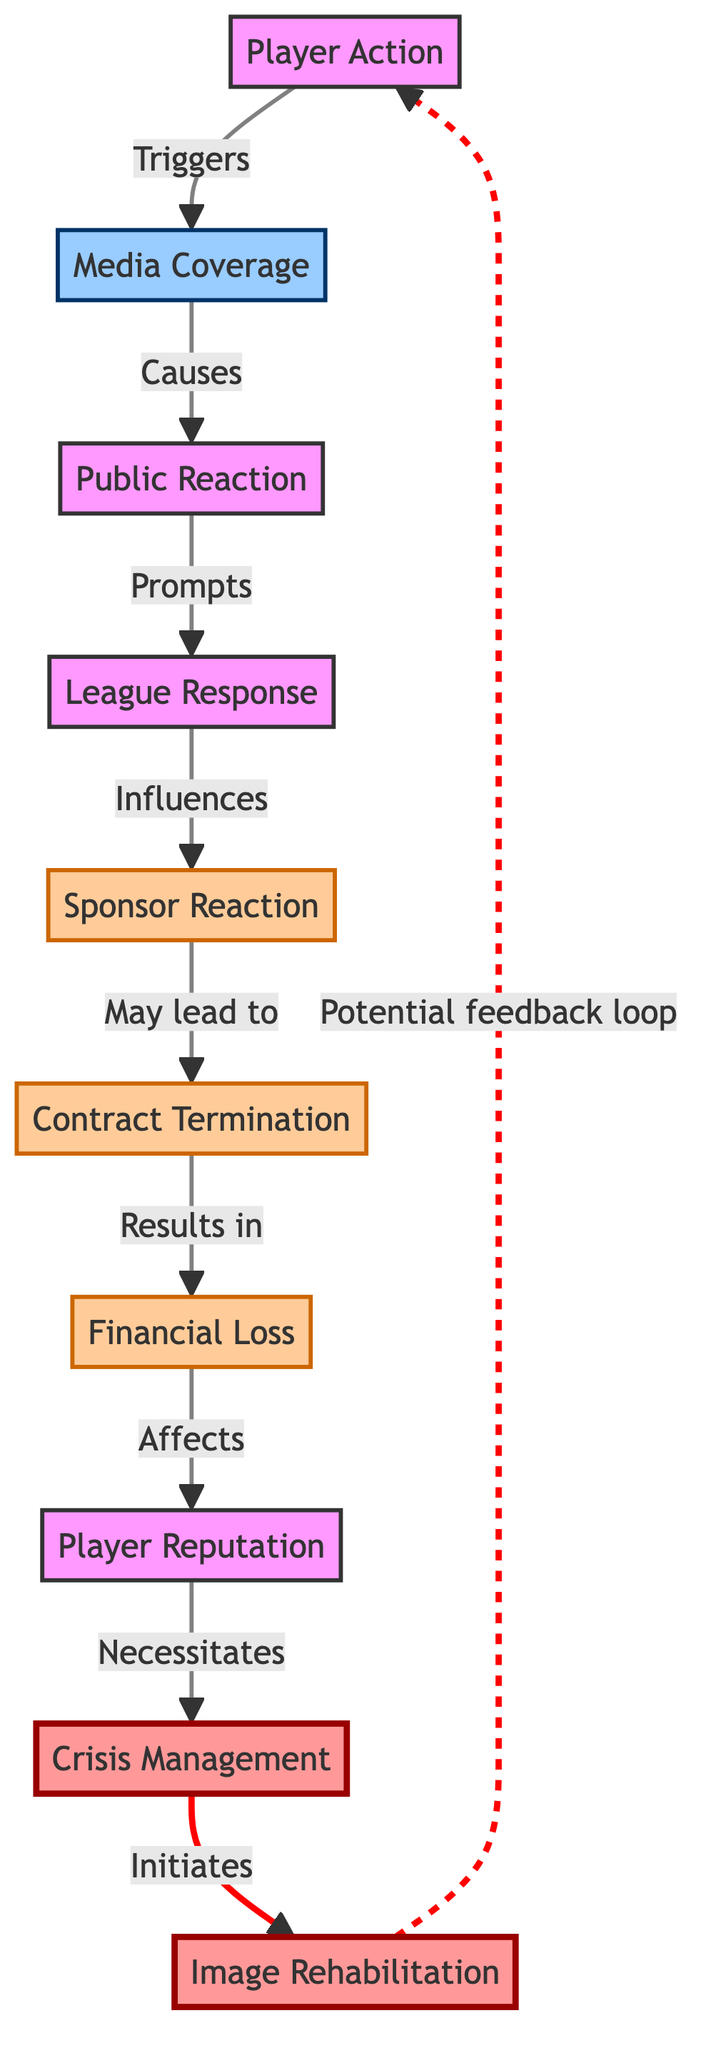What triggers media coverage? The diagram indicates that Player Action triggers Media Coverage. Player actions, such as issues on or off the field, can attract the attention of the media.
Answer: Player Action What leads to financial loss? The diagram shows that Contract Termination may lead to Financial Loss. When sponsorship contracts are terminated, this directly results in a loss of income for the player.
Answer: Contract Termination How does public reaction influence sponsor reaction? From the diagram, Public Reaction prompts League Response, which in turn influences Sponsor Reaction. This indicates a chain where the public's sentiment can affect how sponsors react to a situation.
Answer: Influences What follows after crisis management? According to the diagram, after Crisis Management, Image Rehabilitation is initiated. This indicates the process of restoring a player's public image following a negative event.
Answer: Image Rehabilitation How many nodes are in the diagram? The diagram consists of a total of 10 nodes, including Player Action, Media Coverage, Public Reaction, League Response, Sponsor Reaction, Contract Termination, Financial Loss, Player Reputation, Crisis Management, and Image Rehabilitation.
Answer: 10 Which node is affected by financial loss? Financial Loss affects Player Reputation according to the diagram. This suggests that losing financial support can lead to a negative perception of the player by fans and sponsors.
Answer: Player Reputation What is the response from the league after public reaction? The League Response follows Public Reaction as indicated in the diagram. This shows that the league takes action based on how the public perceives an incident involving players.
Answer: League Response What is the relationship between sponsor reaction and contract termination? The diagram illustrates that Sponsor Reaction may lead to Contract Termination. This means that sponsors might decide to end their contracts based on their reactions to events surrounding the player.
Answer: May lead to What type of feedback loop is shown in the diagram? The diagram indicates a potential feedback loop between Image Rehabilitation and Player Action. This suggests that improved player image may lead to better actions in the future and vice-versa.
Answer: Potential feedback loop 